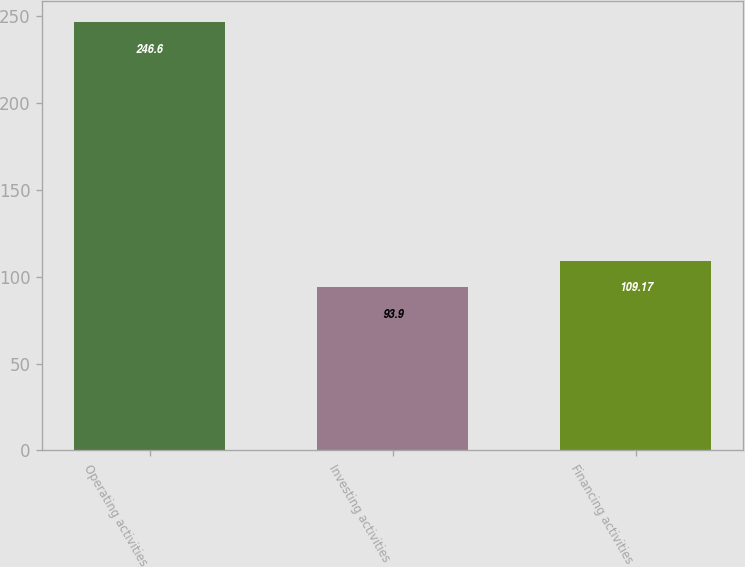Convert chart to OTSL. <chart><loc_0><loc_0><loc_500><loc_500><bar_chart><fcel>Operating activities<fcel>Investing activities<fcel>Financing activities<nl><fcel>246.6<fcel>93.9<fcel>109.17<nl></chart> 